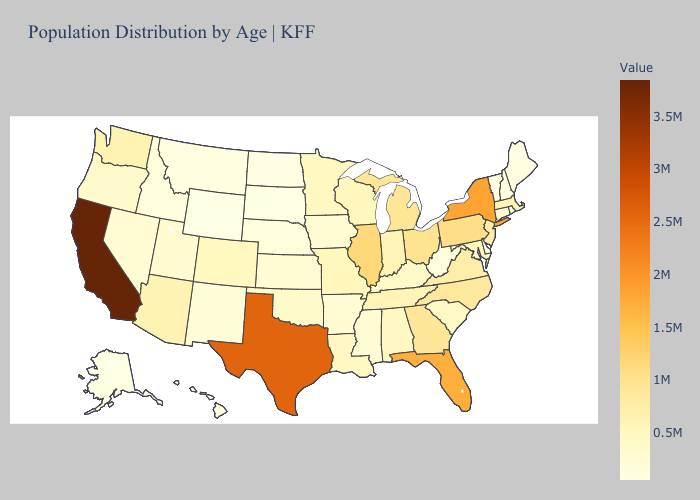Does California have the highest value in the USA?
Concise answer only. Yes. Does Tennessee have the lowest value in the USA?
Concise answer only. No. Does Delaware have the lowest value in the South?
Concise answer only. Yes. Among the states that border Massachusetts , does New Hampshire have the highest value?
Short answer required. No. Is the legend a continuous bar?
Be succinct. Yes. 